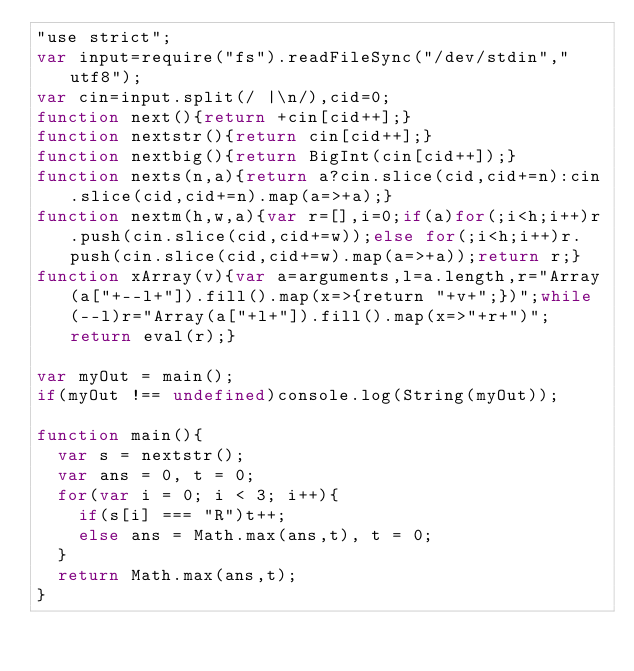<code> <loc_0><loc_0><loc_500><loc_500><_JavaScript_>"use strict";
var input=require("fs").readFileSync("/dev/stdin","utf8");
var cin=input.split(/ |\n/),cid=0;
function next(){return +cin[cid++];}
function nextstr(){return cin[cid++];}
function nextbig(){return BigInt(cin[cid++]);}
function nexts(n,a){return a?cin.slice(cid,cid+=n):cin.slice(cid,cid+=n).map(a=>+a);}
function nextm(h,w,a){var r=[],i=0;if(a)for(;i<h;i++)r.push(cin.slice(cid,cid+=w));else for(;i<h;i++)r.push(cin.slice(cid,cid+=w).map(a=>+a));return r;}
function xArray(v){var a=arguments,l=a.length,r="Array(a["+--l+"]).fill().map(x=>{return "+v+";})";while(--l)r="Array(a["+l+"]).fill().map(x=>"+r+")";return eval(r);}

var myOut = main();
if(myOut !== undefined)console.log(String(myOut));

function main(){
  var s = nextstr();
  var ans = 0, t = 0;
  for(var i = 0; i < 3; i++){
    if(s[i] === "R")t++;
    else ans = Math.max(ans,t), t = 0;
  }
  return Math.max(ans,t);
}</code> 